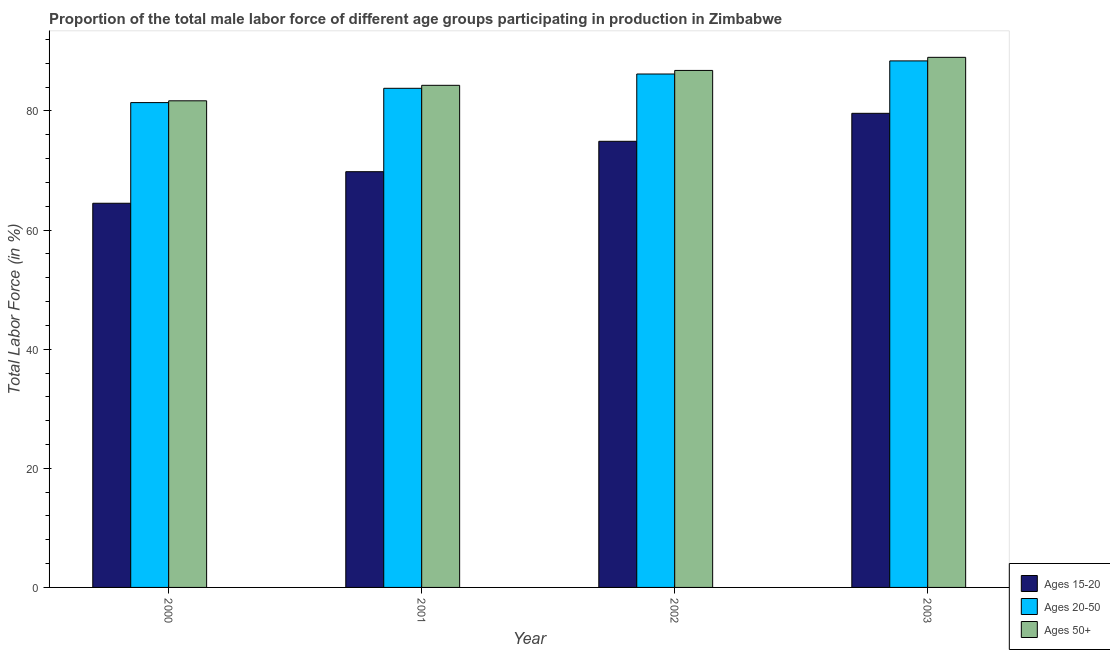How many groups of bars are there?
Offer a terse response. 4. How many bars are there on the 3rd tick from the left?
Make the answer very short. 3. What is the label of the 1st group of bars from the left?
Ensure brevity in your answer.  2000. What is the percentage of male labor force above age 50 in 2003?
Offer a very short reply. 89. Across all years, what is the maximum percentage of male labor force above age 50?
Ensure brevity in your answer.  89. Across all years, what is the minimum percentage of male labor force within the age group 20-50?
Ensure brevity in your answer.  81.4. In which year was the percentage of male labor force above age 50 minimum?
Ensure brevity in your answer.  2000. What is the total percentage of male labor force within the age group 15-20 in the graph?
Your response must be concise. 288.8. What is the difference between the percentage of male labor force within the age group 15-20 in 2000 and the percentage of male labor force above age 50 in 2003?
Your response must be concise. -15.1. What is the average percentage of male labor force within the age group 15-20 per year?
Keep it short and to the point. 72.2. In the year 2001, what is the difference between the percentage of male labor force above age 50 and percentage of male labor force within the age group 20-50?
Provide a short and direct response. 0. What is the ratio of the percentage of male labor force within the age group 15-20 in 2002 to that in 2003?
Give a very brief answer. 0.94. Is the difference between the percentage of male labor force within the age group 15-20 in 2002 and 2003 greater than the difference between the percentage of male labor force within the age group 20-50 in 2002 and 2003?
Your answer should be compact. No. What is the difference between the highest and the second highest percentage of male labor force within the age group 15-20?
Provide a short and direct response. 4.7. What is the difference between the highest and the lowest percentage of male labor force within the age group 15-20?
Give a very brief answer. 15.1. In how many years, is the percentage of male labor force within the age group 20-50 greater than the average percentage of male labor force within the age group 20-50 taken over all years?
Provide a succinct answer. 2. Is the sum of the percentage of male labor force above age 50 in 2000 and 2001 greater than the maximum percentage of male labor force within the age group 20-50 across all years?
Your response must be concise. Yes. What does the 2nd bar from the left in 2001 represents?
Ensure brevity in your answer.  Ages 20-50. What does the 1st bar from the right in 2002 represents?
Ensure brevity in your answer.  Ages 50+. Is it the case that in every year, the sum of the percentage of male labor force within the age group 15-20 and percentage of male labor force within the age group 20-50 is greater than the percentage of male labor force above age 50?
Your answer should be compact. Yes. How many bars are there?
Offer a very short reply. 12. Are all the bars in the graph horizontal?
Make the answer very short. No. What is the difference between two consecutive major ticks on the Y-axis?
Ensure brevity in your answer.  20. Are the values on the major ticks of Y-axis written in scientific E-notation?
Your answer should be very brief. No. Does the graph contain any zero values?
Your answer should be very brief. No. Does the graph contain grids?
Your answer should be compact. No. What is the title of the graph?
Offer a very short reply. Proportion of the total male labor force of different age groups participating in production in Zimbabwe. What is the label or title of the Y-axis?
Offer a terse response. Total Labor Force (in %). What is the Total Labor Force (in %) of Ages 15-20 in 2000?
Give a very brief answer. 64.5. What is the Total Labor Force (in %) of Ages 20-50 in 2000?
Ensure brevity in your answer.  81.4. What is the Total Labor Force (in %) in Ages 50+ in 2000?
Make the answer very short. 81.7. What is the Total Labor Force (in %) of Ages 15-20 in 2001?
Provide a short and direct response. 69.8. What is the Total Labor Force (in %) of Ages 20-50 in 2001?
Provide a succinct answer. 83.8. What is the Total Labor Force (in %) of Ages 50+ in 2001?
Your response must be concise. 84.3. What is the Total Labor Force (in %) in Ages 15-20 in 2002?
Give a very brief answer. 74.9. What is the Total Labor Force (in %) of Ages 20-50 in 2002?
Give a very brief answer. 86.2. What is the Total Labor Force (in %) in Ages 50+ in 2002?
Your response must be concise. 86.8. What is the Total Labor Force (in %) of Ages 15-20 in 2003?
Your response must be concise. 79.6. What is the Total Labor Force (in %) in Ages 20-50 in 2003?
Make the answer very short. 88.4. What is the Total Labor Force (in %) in Ages 50+ in 2003?
Provide a short and direct response. 89. Across all years, what is the maximum Total Labor Force (in %) in Ages 15-20?
Offer a very short reply. 79.6. Across all years, what is the maximum Total Labor Force (in %) of Ages 20-50?
Ensure brevity in your answer.  88.4. Across all years, what is the maximum Total Labor Force (in %) in Ages 50+?
Offer a very short reply. 89. Across all years, what is the minimum Total Labor Force (in %) in Ages 15-20?
Provide a short and direct response. 64.5. Across all years, what is the minimum Total Labor Force (in %) in Ages 20-50?
Make the answer very short. 81.4. Across all years, what is the minimum Total Labor Force (in %) in Ages 50+?
Provide a succinct answer. 81.7. What is the total Total Labor Force (in %) in Ages 15-20 in the graph?
Ensure brevity in your answer.  288.8. What is the total Total Labor Force (in %) of Ages 20-50 in the graph?
Your answer should be very brief. 339.8. What is the total Total Labor Force (in %) in Ages 50+ in the graph?
Provide a succinct answer. 341.8. What is the difference between the Total Labor Force (in %) of Ages 15-20 in 2000 and that in 2001?
Give a very brief answer. -5.3. What is the difference between the Total Labor Force (in %) in Ages 20-50 in 2000 and that in 2001?
Keep it short and to the point. -2.4. What is the difference between the Total Labor Force (in %) of Ages 20-50 in 2000 and that in 2002?
Provide a succinct answer. -4.8. What is the difference between the Total Labor Force (in %) of Ages 15-20 in 2000 and that in 2003?
Offer a very short reply. -15.1. What is the difference between the Total Labor Force (in %) of Ages 20-50 in 2000 and that in 2003?
Provide a succinct answer. -7. What is the difference between the Total Labor Force (in %) in Ages 50+ in 2000 and that in 2003?
Keep it short and to the point. -7.3. What is the difference between the Total Labor Force (in %) of Ages 15-20 in 2001 and that in 2002?
Give a very brief answer. -5.1. What is the difference between the Total Labor Force (in %) of Ages 20-50 in 2001 and that in 2002?
Your response must be concise. -2.4. What is the difference between the Total Labor Force (in %) in Ages 15-20 in 2001 and that in 2003?
Give a very brief answer. -9.8. What is the difference between the Total Labor Force (in %) of Ages 50+ in 2001 and that in 2003?
Make the answer very short. -4.7. What is the difference between the Total Labor Force (in %) in Ages 15-20 in 2002 and that in 2003?
Your answer should be very brief. -4.7. What is the difference between the Total Labor Force (in %) in Ages 50+ in 2002 and that in 2003?
Offer a terse response. -2.2. What is the difference between the Total Labor Force (in %) in Ages 15-20 in 2000 and the Total Labor Force (in %) in Ages 20-50 in 2001?
Offer a very short reply. -19.3. What is the difference between the Total Labor Force (in %) in Ages 15-20 in 2000 and the Total Labor Force (in %) in Ages 50+ in 2001?
Give a very brief answer. -19.8. What is the difference between the Total Labor Force (in %) in Ages 15-20 in 2000 and the Total Labor Force (in %) in Ages 20-50 in 2002?
Keep it short and to the point. -21.7. What is the difference between the Total Labor Force (in %) of Ages 15-20 in 2000 and the Total Labor Force (in %) of Ages 50+ in 2002?
Your answer should be compact. -22.3. What is the difference between the Total Labor Force (in %) in Ages 15-20 in 2000 and the Total Labor Force (in %) in Ages 20-50 in 2003?
Offer a terse response. -23.9. What is the difference between the Total Labor Force (in %) in Ages 15-20 in 2000 and the Total Labor Force (in %) in Ages 50+ in 2003?
Give a very brief answer. -24.5. What is the difference between the Total Labor Force (in %) in Ages 15-20 in 2001 and the Total Labor Force (in %) in Ages 20-50 in 2002?
Provide a short and direct response. -16.4. What is the difference between the Total Labor Force (in %) in Ages 15-20 in 2001 and the Total Labor Force (in %) in Ages 20-50 in 2003?
Provide a succinct answer. -18.6. What is the difference between the Total Labor Force (in %) in Ages 15-20 in 2001 and the Total Labor Force (in %) in Ages 50+ in 2003?
Your response must be concise. -19.2. What is the difference between the Total Labor Force (in %) in Ages 15-20 in 2002 and the Total Labor Force (in %) in Ages 20-50 in 2003?
Your response must be concise. -13.5. What is the difference between the Total Labor Force (in %) in Ages 15-20 in 2002 and the Total Labor Force (in %) in Ages 50+ in 2003?
Offer a terse response. -14.1. What is the difference between the Total Labor Force (in %) of Ages 20-50 in 2002 and the Total Labor Force (in %) of Ages 50+ in 2003?
Provide a short and direct response. -2.8. What is the average Total Labor Force (in %) of Ages 15-20 per year?
Offer a very short reply. 72.2. What is the average Total Labor Force (in %) in Ages 20-50 per year?
Provide a succinct answer. 84.95. What is the average Total Labor Force (in %) in Ages 50+ per year?
Your answer should be compact. 85.45. In the year 2000, what is the difference between the Total Labor Force (in %) of Ages 15-20 and Total Labor Force (in %) of Ages 20-50?
Ensure brevity in your answer.  -16.9. In the year 2000, what is the difference between the Total Labor Force (in %) in Ages 15-20 and Total Labor Force (in %) in Ages 50+?
Your answer should be compact. -17.2. In the year 2001, what is the difference between the Total Labor Force (in %) in Ages 15-20 and Total Labor Force (in %) in Ages 50+?
Keep it short and to the point. -14.5. In the year 2002, what is the difference between the Total Labor Force (in %) of Ages 15-20 and Total Labor Force (in %) of Ages 50+?
Offer a terse response. -11.9. In the year 2002, what is the difference between the Total Labor Force (in %) of Ages 20-50 and Total Labor Force (in %) of Ages 50+?
Provide a short and direct response. -0.6. In the year 2003, what is the difference between the Total Labor Force (in %) of Ages 15-20 and Total Labor Force (in %) of Ages 20-50?
Your response must be concise. -8.8. In the year 2003, what is the difference between the Total Labor Force (in %) in Ages 15-20 and Total Labor Force (in %) in Ages 50+?
Offer a very short reply. -9.4. In the year 2003, what is the difference between the Total Labor Force (in %) of Ages 20-50 and Total Labor Force (in %) of Ages 50+?
Make the answer very short. -0.6. What is the ratio of the Total Labor Force (in %) of Ages 15-20 in 2000 to that in 2001?
Ensure brevity in your answer.  0.92. What is the ratio of the Total Labor Force (in %) in Ages 20-50 in 2000 to that in 2001?
Offer a terse response. 0.97. What is the ratio of the Total Labor Force (in %) of Ages 50+ in 2000 to that in 2001?
Ensure brevity in your answer.  0.97. What is the ratio of the Total Labor Force (in %) in Ages 15-20 in 2000 to that in 2002?
Give a very brief answer. 0.86. What is the ratio of the Total Labor Force (in %) of Ages 20-50 in 2000 to that in 2002?
Your answer should be compact. 0.94. What is the ratio of the Total Labor Force (in %) of Ages 15-20 in 2000 to that in 2003?
Provide a succinct answer. 0.81. What is the ratio of the Total Labor Force (in %) of Ages 20-50 in 2000 to that in 2003?
Provide a succinct answer. 0.92. What is the ratio of the Total Labor Force (in %) of Ages 50+ in 2000 to that in 2003?
Your answer should be compact. 0.92. What is the ratio of the Total Labor Force (in %) in Ages 15-20 in 2001 to that in 2002?
Your response must be concise. 0.93. What is the ratio of the Total Labor Force (in %) of Ages 20-50 in 2001 to that in 2002?
Ensure brevity in your answer.  0.97. What is the ratio of the Total Labor Force (in %) in Ages 50+ in 2001 to that in 2002?
Make the answer very short. 0.97. What is the ratio of the Total Labor Force (in %) in Ages 15-20 in 2001 to that in 2003?
Give a very brief answer. 0.88. What is the ratio of the Total Labor Force (in %) in Ages 20-50 in 2001 to that in 2003?
Offer a very short reply. 0.95. What is the ratio of the Total Labor Force (in %) of Ages 50+ in 2001 to that in 2003?
Give a very brief answer. 0.95. What is the ratio of the Total Labor Force (in %) of Ages 15-20 in 2002 to that in 2003?
Keep it short and to the point. 0.94. What is the ratio of the Total Labor Force (in %) of Ages 20-50 in 2002 to that in 2003?
Provide a succinct answer. 0.98. What is the ratio of the Total Labor Force (in %) of Ages 50+ in 2002 to that in 2003?
Provide a succinct answer. 0.98. What is the difference between the highest and the second highest Total Labor Force (in %) in Ages 15-20?
Offer a terse response. 4.7. What is the difference between the highest and the second highest Total Labor Force (in %) in Ages 20-50?
Give a very brief answer. 2.2. What is the difference between the highest and the lowest Total Labor Force (in %) in Ages 15-20?
Provide a short and direct response. 15.1. What is the difference between the highest and the lowest Total Labor Force (in %) of Ages 20-50?
Keep it short and to the point. 7. 